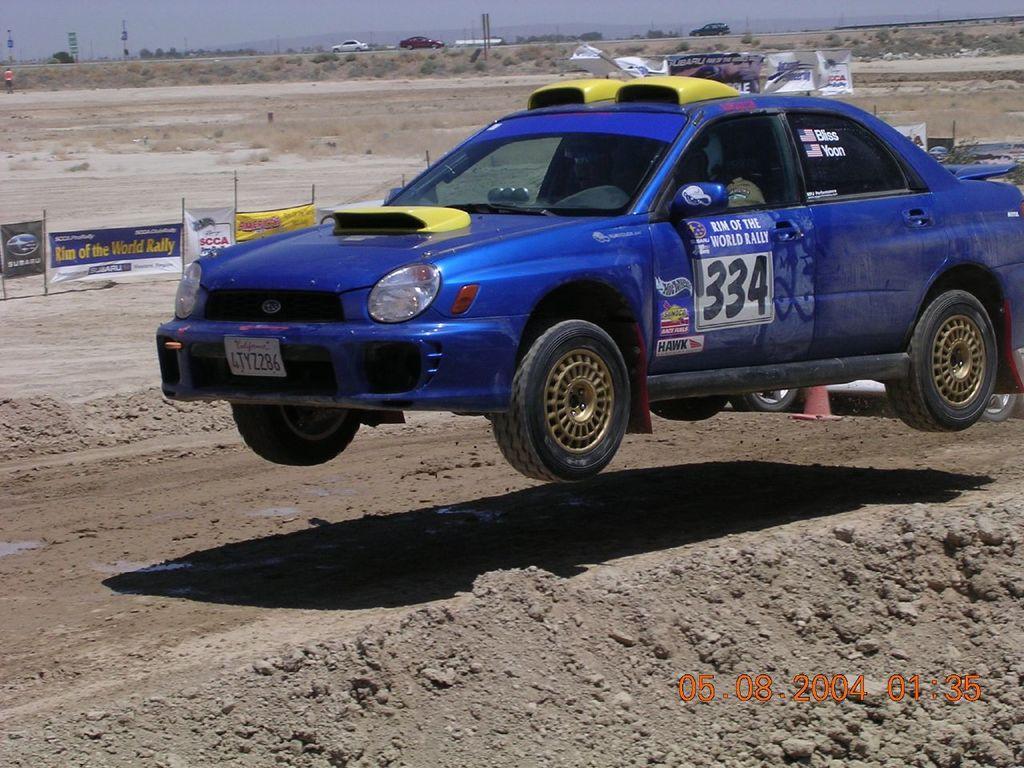Describe this image in one or two sentences. In this image we can see few vehicles. There are many advertising boards in the image. We can see the sky in the image. There are few people in the image. 